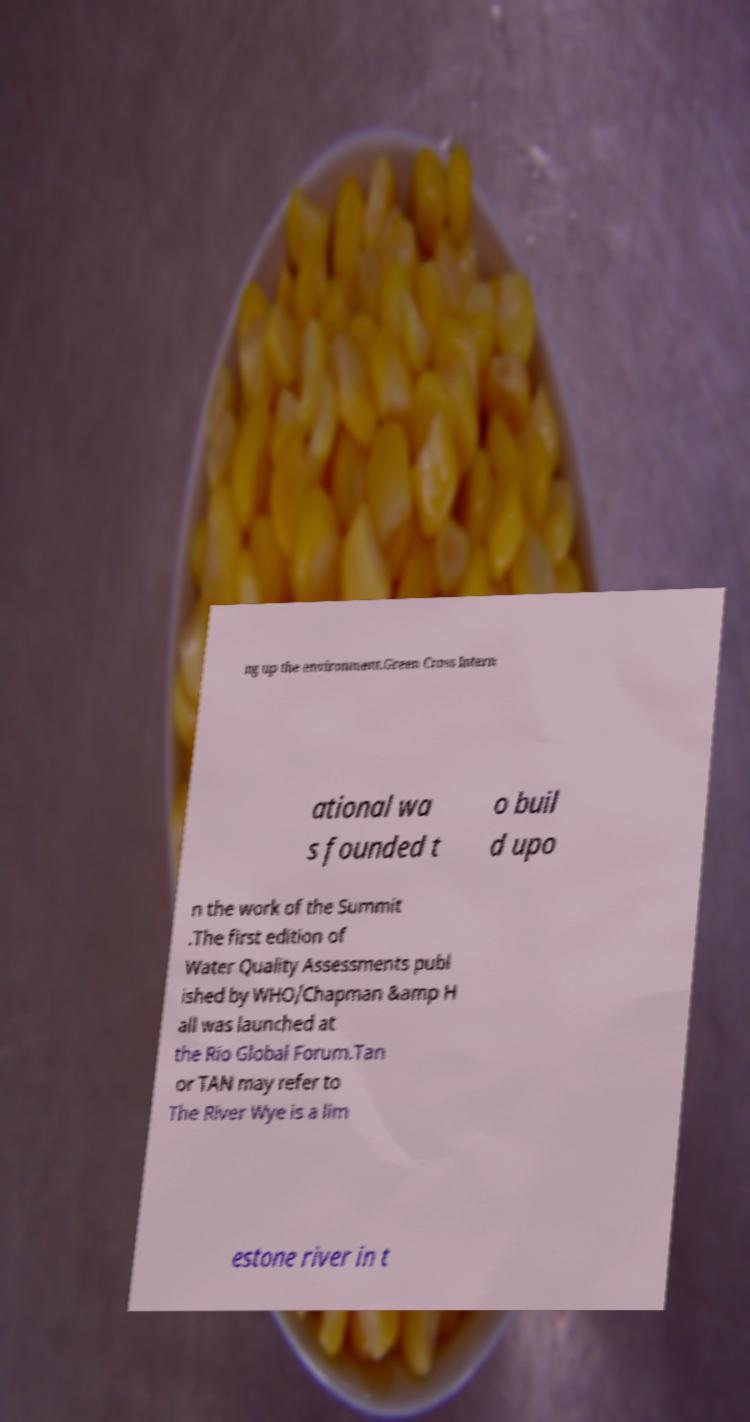Could you assist in decoding the text presented in this image and type it out clearly? ng up the environment.Green Cross Intern ational wa s founded t o buil d upo n the work of the Summit .The first edition of Water Quality Assessments publ ished by WHO/Chapman &amp H all was launched at the Rio Global Forum.Tan or TAN may refer to The River Wye is a lim estone river in t 